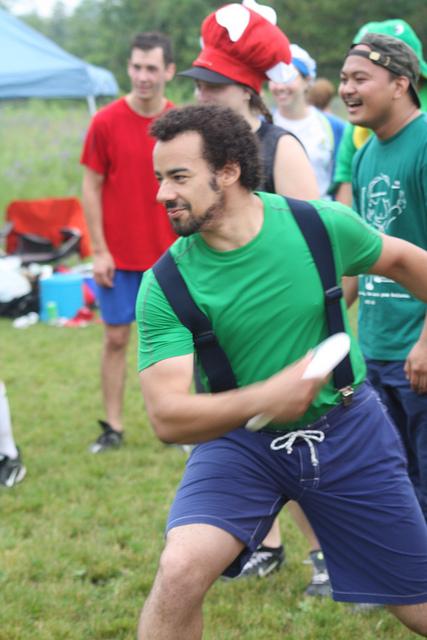What is attached to the shores of the man in the green shirt?
Concise answer only. Suspenders. What is the man in the front about to throw?
Quick response, please. Frisbee. Does the guy in the green shirt look happy?
Answer briefly. Yes. How many faces can be seen?
Give a very brief answer. 5. 